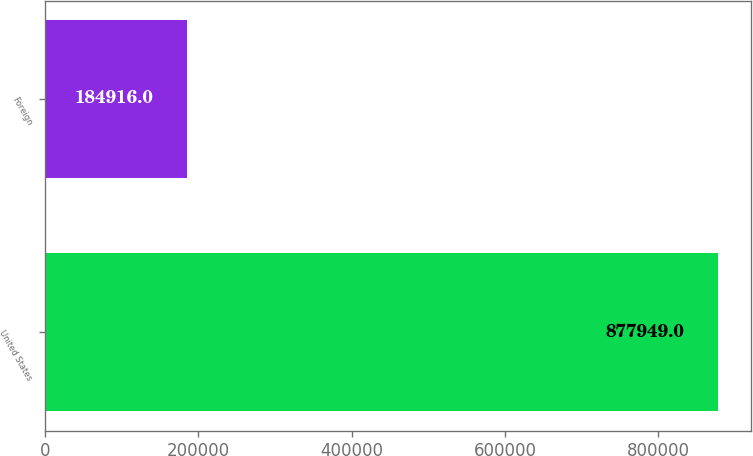<chart> <loc_0><loc_0><loc_500><loc_500><bar_chart><fcel>United States<fcel>Foreign<nl><fcel>877949<fcel>184916<nl></chart> 